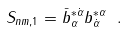<formula> <loc_0><loc_0><loc_500><loc_500>S _ { n m , 1 } = \bar { b } _ { \alpha } ^ { * \dot { \alpha } } b _ { \dot { \alpha } } ^ { * \alpha } \ .</formula> 